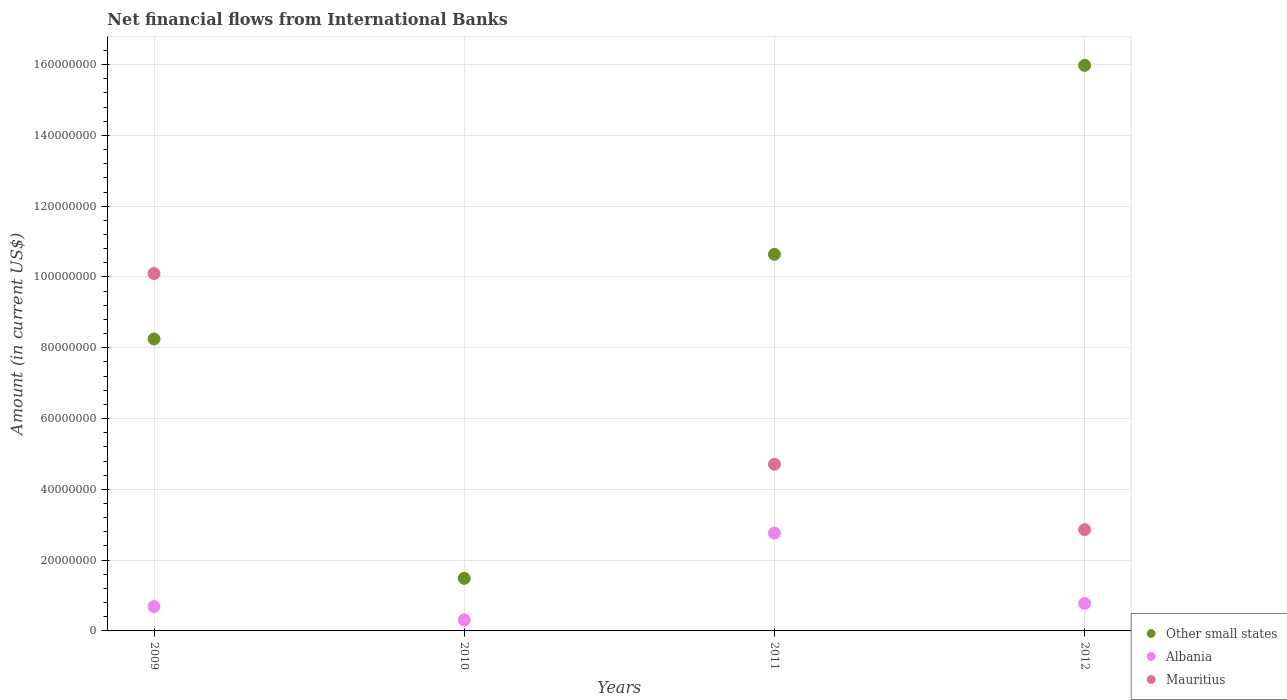What is the net financial aid flows in Mauritius in 2009?
Give a very brief answer. 1.01e+08. Across all years, what is the maximum net financial aid flows in Albania?
Offer a terse response. 2.76e+07. Across all years, what is the minimum net financial aid flows in Other small states?
Make the answer very short. 1.49e+07. What is the total net financial aid flows in Albania in the graph?
Provide a succinct answer. 4.54e+07. What is the difference between the net financial aid flows in Albania in 2009 and that in 2011?
Provide a short and direct response. -2.08e+07. What is the difference between the net financial aid flows in Albania in 2009 and the net financial aid flows in Other small states in 2010?
Offer a very short reply. -7.98e+06. What is the average net financial aid flows in Mauritius per year?
Provide a short and direct response. 4.42e+07. In the year 2010, what is the difference between the net financial aid flows in Albania and net financial aid flows in Other small states?
Your answer should be very brief. -1.18e+07. In how many years, is the net financial aid flows in Mauritius greater than 160000000 US$?
Keep it short and to the point. 0. What is the ratio of the net financial aid flows in Mauritius in 2009 to that in 2012?
Ensure brevity in your answer.  3.53. Is the difference between the net financial aid flows in Albania in 2010 and 2012 greater than the difference between the net financial aid flows in Other small states in 2010 and 2012?
Provide a short and direct response. Yes. What is the difference between the highest and the second highest net financial aid flows in Other small states?
Your answer should be compact. 5.34e+07. What is the difference between the highest and the lowest net financial aid flows in Albania?
Your answer should be compact. 2.45e+07. In how many years, is the net financial aid flows in Albania greater than the average net financial aid flows in Albania taken over all years?
Your response must be concise. 1. Does the net financial aid flows in Albania monotonically increase over the years?
Your answer should be compact. No. Is the net financial aid flows in Mauritius strictly less than the net financial aid flows in Other small states over the years?
Your response must be concise. No. What is the difference between two consecutive major ticks on the Y-axis?
Your response must be concise. 2.00e+07. Does the graph contain any zero values?
Your answer should be compact. Yes. Does the graph contain grids?
Your answer should be very brief. Yes. Where does the legend appear in the graph?
Your answer should be very brief. Bottom right. How are the legend labels stacked?
Offer a terse response. Vertical. What is the title of the graph?
Your response must be concise. Net financial flows from International Banks. Does "Estonia" appear as one of the legend labels in the graph?
Your answer should be compact. No. What is the label or title of the X-axis?
Your answer should be compact. Years. What is the Amount (in current US$) in Other small states in 2009?
Provide a succinct answer. 8.25e+07. What is the Amount (in current US$) of Albania in 2009?
Provide a succinct answer. 6.87e+06. What is the Amount (in current US$) in Mauritius in 2009?
Make the answer very short. 1.01e+08. What is the Amount (in current US$) in Other small states in 2010?
Your answer should be compact. 1.49e+07. What is the Amount (in current US$) of Albania in 2010?
Offer a very short reply. 3.11e+06. What is the Amount (in current US$) in Other small states in 2011?
Your answer should be very brief. 1.06e+08. What is the Amount (in current US$) in Albania in 2011?
Provide a succinct answer. 2.76e+07. What is the Amount (in current US$) in Mauritius in 2011?
Offer a terse response. 4.71e+07. What is the Amount (in current US$) in Other small states in 2012?
Keep it short and to the point. 1.60e+08. What is the Amount (in current US$) of Albania in 2012?
Make the answer very short. 7.76e+06. What is the Amount (in current US$) in Mauritius in 2012?
Ensure brevity in your answer.  2.86e+07. Across all years, what is the maximum Amount (in current US$) of Other small states?
Your answer should be very brief. 1.60e+08. Across all years, what is the maximum Amount (in current US$) of Albania?
Give a very brief answer. 2.76e+07. Across all years, what is the maximum Amount (in current US$) of Mauritius?
Offer a terse response. 1.01e+08. Across all years, what is the minimum Amount (in current US$) of Other small states?
Offer a terse response. 1.49e+07. Across all years, what is the minimum Amount (in current US$) of Albania?
Provide a succinct answer. 3.11e+06. Across all years, what is the minimum Amount (in current US$) of Mauritius?
Offer a very short reply. 0. What is the total Amount (in current US$) of Other small states in the graph?
Provide a short and direct response. 3.64e+08. What is the total Amount (in current US$) of Albania in the graph?
Your answer should be compact. 4.54e+07. What is the total Amount (in current US$) of Mauritius in the graph?
Offer a terse response. 1.77e+08. What is the difference between the Amount (in current US$) in Other small states in 2009 and that in 2010?
Your response must be concise. 6.76e+07. What is the difference between the Amount (in current US$) in Albania in 2009 and that in 2010?
Your answer should be very brief. 3.77e+06. What is the difference between the Amount (in current US$) of Other small states in 2009 and that in 2011?
Keep it short and to the point. -2.39e+07. What is the difference between the Amount (in current US$) of Albania in 2009 and that in 2011?
Give a very brief answer. -2.08e+07. What is the difference between the Amount (in current US$) in Mauritius in 2009 and that in 2011?
Your answer should be very brief. 5.39e+07. What is the difference between the Amount (in current US$) of Other small states in 2009 and that in 2012?
Make the answer very short. -7.73e+07. What is the difference between the Amount (in current US$) of Albania in 2009 and that in 2012?
Ensure brevity in your answer.  -8.86e+05. What is the difference between the Amount (in current US$) of Mauritius in 2009 and that in 2012?
Give a very brief answer. 7.24e+07. What is the difference between the Amount (in current US$) of Other small states in 2010 and that in 2011?
Your answer should be compact. -9.16e+07. What is the difference between the Amount (in current US$) of Albania in 2010 and that in 2011?
Offer a terse response. -2.45e+07. What is the difference between the Amount (in current US$) of Other small states in 2010 and that in 2012?
Offer a very short reply. -1.45e+08. What is the difference between the Amount (in current US$) in Albania in 2010 and that in 2012?
Make the answer very short. -4.65e+06. What is the difference between the Amount (in current US$) of Other small states in 2011 and that in 2012?
Keep it short and to the point. -5.34e+07. What is the difference between the Amount (in current US$) in Albania in 2011 and that in 2012?
Your answer should be very brief. 1.99e+07. What is the difference between the Amount (in current US$) in Mauritius in 2011 and that in 2012?
Keep it short and to the point. 1.85e+07. What is the difference between the Amount (in current US$) of Other small states in 2009 and the Amount (in current US$) of Albania in 2010?
Provide a short and direct response. 7.94e+07. What is the difference between the Amount (in current US$) of Other small states in 2009 and the Amount (in current US$) of Albania in 2011?
Ensure brevity in your answer.  5.49e+07. What is the difference between the Amount (in current US$) of Other small states in 2009 and the Amount (in current US$) of Mauritius in 2011?
Your answer should be compact. 3.54e+07. What is the difference between the Amount (in current US$) in Albania in 2009 and the Amount (in current US$) in Mauritius in 2011?
Your answer should be compact. -4.02e+07. What is the difference between the Amount (in current US$) of Other small states in 2009 and the Amount (in current US$) of Albania in 2012?
Give a very brief answer. 7.47e+07. What is the difference between the Amount (in current US$) in Other small states in 2009 and the Amount (in current US$) in Mauritius in 2012?
Your response must be concise. 5.39e+07. What is the difference between the Amount (in current US$) of Albania in 2009 and the Amount (in current US$) of Mauritius in 2012?
Your answer should be very brief. -2.17e+07. What is the difference between the Amount (in current US$) in Other small states in 2010 and the Amount (in current US$) in Albania in 2011?
Make the answer very short. -1.28e+07. What is the difference between the Amount (in current US$) in Other small states in 2010 and the Amount (in current US$) in Mauritius in 2011?
Keep it short and to the point. -3.22e+07. What is the difference between the Amount (in current US$) in Albania in 2010 and the Amount (in current US$) in Mauritius in 2011?
Make the answer very short. -4.40e+07. What is the difference between the Amount (in current US$) in Other small states in 2010 and the Amount (in current US$) in Albania in 2012?
Provide a short and direct response. 7.10e+06. What is the difference between the Amount (in current US$) of Other small states in 2010 and the Amount (in current US$) of Mauritius in 2012?
Your response must be concise. -1.37e+07. What is the difference between the Amount (in current US$) of Albania in 2010 and the Amount (in current US$) of Mauritius in 2012?
Give a very brief answer. -2.55e+07. What is the difference between the Amount (in current US$) of Other small states in 2011 and the Amount (in current US$) of Albania in 2012?
Give a very brief answer. 9.87e+07. What is the difference between the Amount (in current US$) in Other small states in 2011 and the Amount (in current US$) in Mauritius in 2012?
Give a very brief answer. 7.78e+07. What is the difference between the Amount (in current US$) in Albania in 2011 and the Amount (in current US$) in Mauritius in 2012?
Keep it short and to the point. -9.67e+05. What is the average Amount (in current US$) in Other small states per year?
Your answer should be compact. 9.09e+07. What is the average Amount (in current US$) of Albania per year?
Ensure brevity in your answer.  1.13e+07. What is the average Amount (in current US$) in Mauritius per year?
Provide a succinct answer. 4.42e+07. In the year 2009, what is the difference between the Amount (in current US$) in Other small states and Amount (in current US$) in Albania?
Give a very brief answer. 7.56e+07. In the year 2009, what is the difference between the Amount (in current US$) of Other small states and Amount (in current US$) of Mauritius?
Give a very brief answer. -1.85e+07. In the year 2009, what is the difference between the Amount (in current US$) in Albania and Amount (in current US$) in Mauritius?
Ensure brevity in your answer.  -9.41e+07. In the year 2010, what is the difference between the Amount (in current US$) in Other small states and Amount (in current US$) in Albania?
Provide a succinct answer. 1.18e+07. In the year 2011, what is the difference between the Amount (in current US$) in Other small states and Amount (in current US$) in Albania?
Make the answer very short. 7.88e+07. In the year 2011, what is the difference between the Amount (in current US$) in Other small states and Amount (in current US$) in Mauritius?
Your response must be concise. 5.93e+07. In the year 2011, what is the difference between the Amount (in current US$) in Albania and Amount (in current US$) in Mauritius?
Offer a very short reply. -1.95e+07. In the year 2012, what is the difference between the Amount (in current US$) of Other small states and Amount (in current US$) of Albania?
Your response must be concise. 1.52e+08. In the year 2012, what is the difference between the Amount (in current US$) in Other small states and Amount (in current US$) in Mauritius?
Your response must be concise. 1.31e+08. In the year 2012, what is the difference between the Amount (in current US$) in Albania and Amount (in current US$) in Mauritius?
Your answer should be compact. -2.08e+07. What is the ratio of the Amount (in current US$) of Other small states in 2009 to that in 2010?
Your answer should be very brief. 5.55. What is the ratio of the Amount (in current US$) in Albania in 2009 to that in 2010?
Your answer should be very brief. 2.21. What is the ratio of the Amount (in current US$) of Other small states in 2009 to that in 2011?
Keep it short and to the point. 0.78. What is the ratio of the Amount (in current US$) in Albania in 2009 to that in 2011?
Ensure brevity in your answer.  0.25. What is the ratio of the Amount (in current US$) of Mauritius in 2009 to that in 2011?
Make the answer very short. 2.14. What is the ratio of the Amount (in current US$) in Other small states in 2009 to that in 2012?
Provide a succinct answer. 0.52. What is the ratio of the Amount (in current US$) of Albania in 2009 to that in 2012?
Keep it short and to the point. 0.89. What is the ratio of the Amount (in current US$) of Mauritius in 2009 to that in 2012?
Your response must be concise. 3.53. What is the ratio of the Amount (in current US$) of Other small states in 2010 to that in 2011?
Provide a short and direct response. 0.14. What is the ratio of the Amount (in current US$) in Albania in 2010 to that in 2011?
Keep it short and to the point. 0.11. What is the ratio of the Amount (in current US$) in Other small states in 2010 to that in 2012?
Your answer should be compact. 0.09. What is the ratio of the Amount (in current US$) in Albania in 2010 to that in 2012?
Provide a short and direct response. 0.4. What is the ratio of the Amount (in current US$) of Other small states in 2011 to that in 2012?
Provide a succinct answer. 0.67. What is the ratio of the Amount (in current US$) in Albania in 2011 to that in 2012?
Your response must be concise. 3.56. What is the ratio of the Amount (in current US$) of Mauritius in 2011 to that in 2012?
Provide a succinct answer. 1.65. What is the difference between the highest and the second highest Amount (in current US$) of Other small states?
Provide a succinct answer. 5.34e+07. What is the difference between the highest and the second highest Amount (in current US$) of Albania?
Offer a very short reply. 1.99e+07. What is the difference between the highest and the second highest Amount (in current US$) in Mauritius?
Your answer should be very brief. 5.39e+07. What is the difference between the highest and the lowest Amount (in current US$) of Other small states?
Your answer should be compact. 1.45e+08. What is the difference between the highest and the lowest Amount (in current US$) in Albania?
Provide a succinct answer. 2.45e+07. What is the difference between the highest and the lowest Amount (in current US$) in Mauritius?
Offer a terse response. 1.01e+08. 